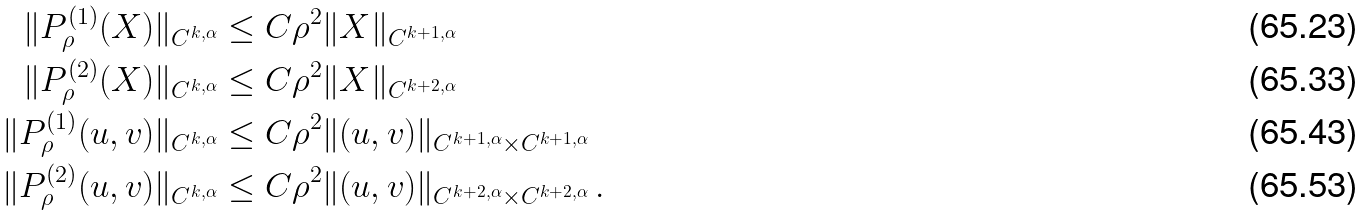<formula> <loc_0><loc_0><loc_500><loc_500>\| P _ { \rho } ^ { ( 1 ) } ( X ) \| _ { C ^ { k , \alpha } } & \leq C \rho ^ { 2 } \| X \| _ { C ^ { k + 1 , \alpha } } \\ \| P _ { \rho } ^ { ( 2 ) } ( X ) \| _ { C ^ { k , \alpha } } & \leq C \rho ^ { 2 } \| X \| _ { C ^ { k + 2 , \alpha } } \\ \| P _ { \rho } ^ { ( 1 ) } ( u , v ) \| _ { C ^ { k , \alpha } } & \leq C \rho ^ { 2 } \| ( u , v ) \| _ { C ^ { k + 1 , \alpha } \times C ^ { k + 1 , \alpha } } \\ \| P _ { \rho } ^ { ( 2 ) } ( u , v ) \| _ { C ^ { k , \alpha } } & \leq C \rho ^ { 2 } \| ( u , v ) \| _ { C ^ { k + 2 , \alpha } \times C ^ { k + 2 , \alpha } } \, .</formula> 